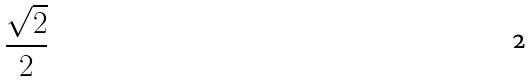Convert formula to latex. <formula><loc_0><loc_0><loc_500><loc_500>\frac { \sqrt { 2 } } { 2 }</formula> 